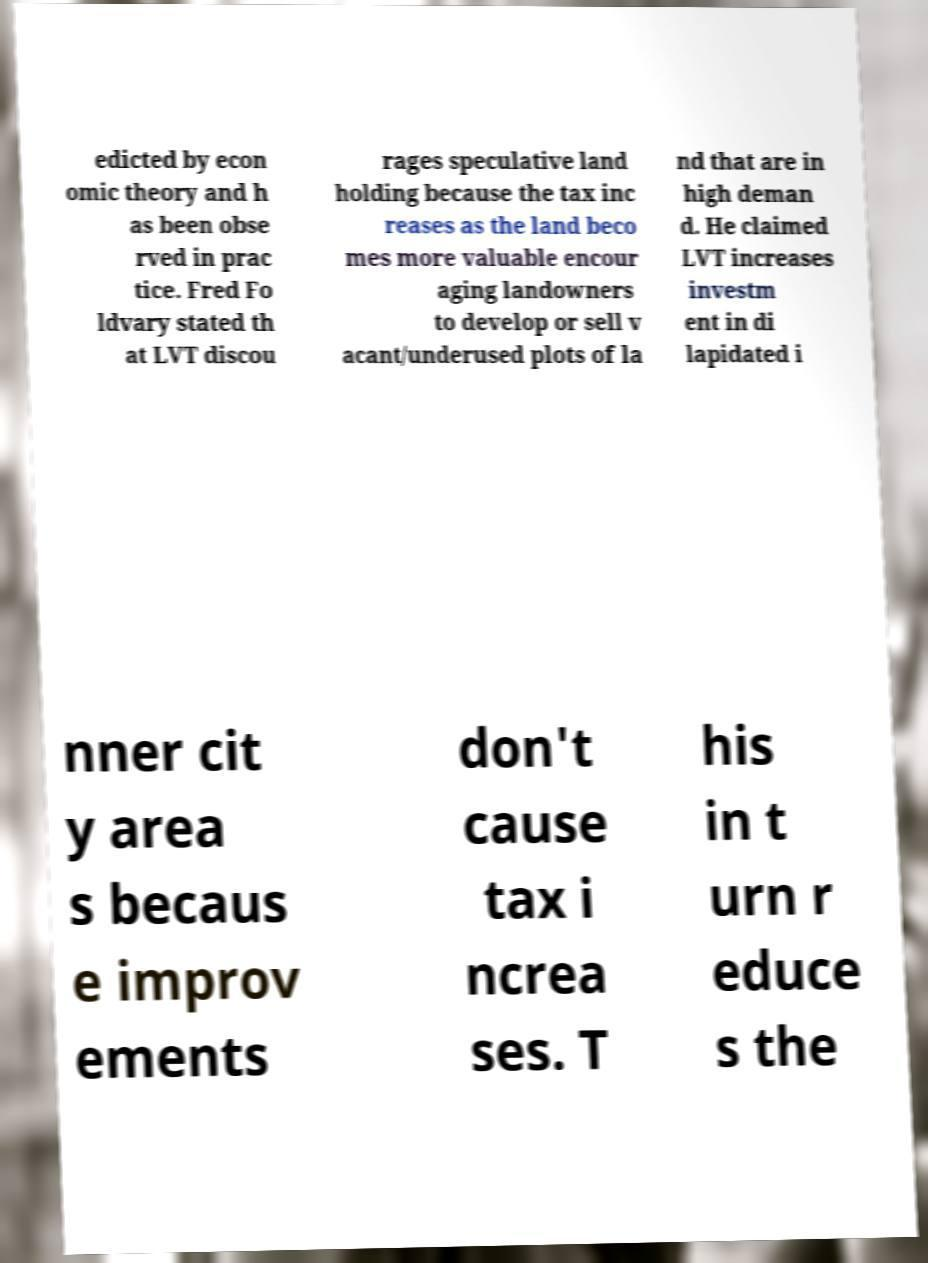Could you extract and type out the text from this image? edicted by econ omic theory and h as been obse rved in prac tice. Fred Fo ldvary stated th at LVT discou rages speculative land holding because the tax inc reases as the land beco mes more valuable encour aging landowners to develop or sell v acant/underused plots of la nd that are in high deman d. He claimed LVT increases investm ent in di lapidated i nner cit y area s becaus e improv ements don't cause tax i ncrea ses. T his in t urn r educe s the 